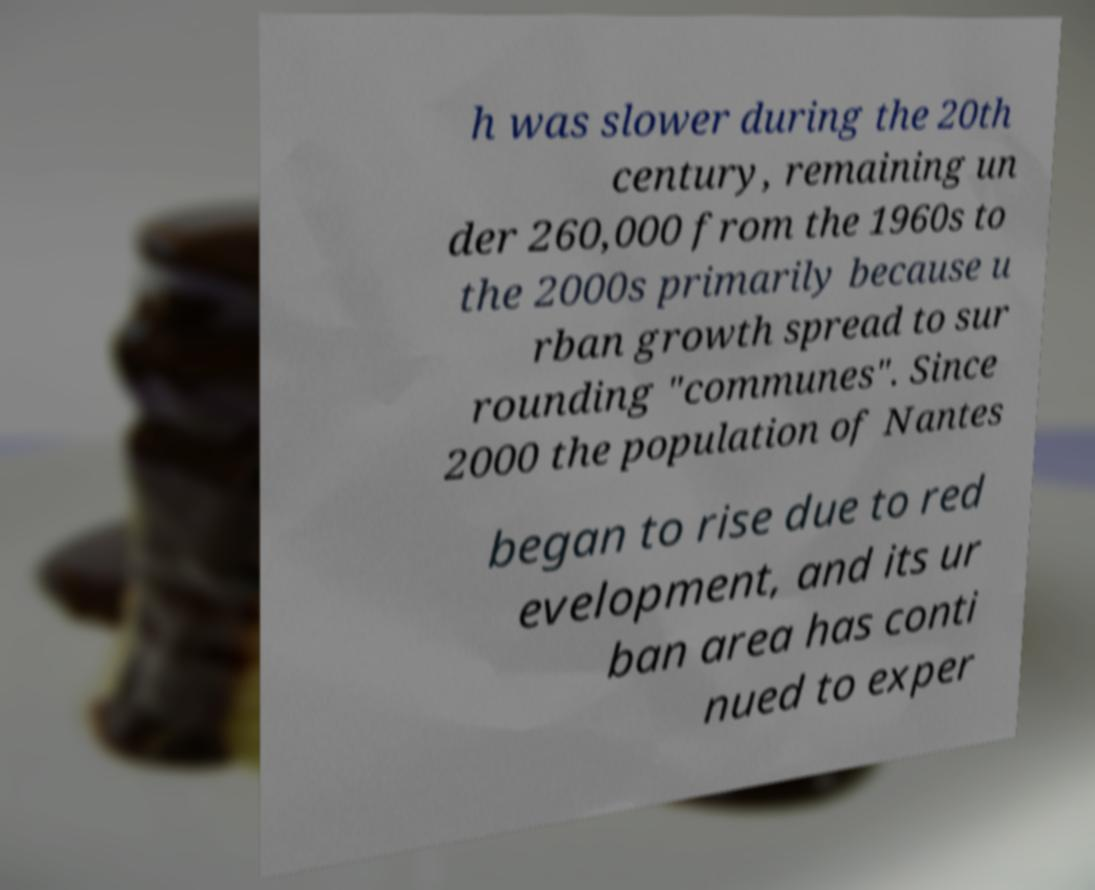Please identify and transcribe the text found in this image. h was slower during the 20th century, remaining un der 260,000 from the 1960s to the 2000s primarily because u rban growth spread to sur rounding "communes". Since 2000 the population of Nantes began to rise due to red evelopment, and its ur ban area has conti nued to exper 